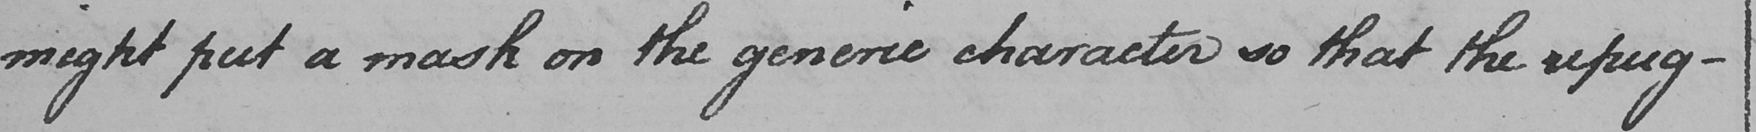Please provide the text content of this handwritten line. might put a mask on the generic character so that the repug- 